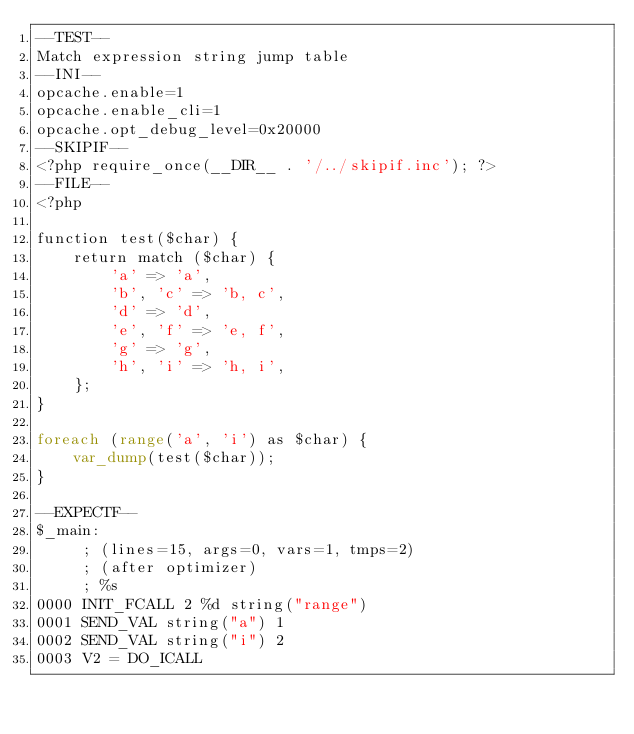<code> <loc_0><loc_0><loc_500><loc_500><_PHP_>--TEST--
Match expression string jump table
--INI--
opcache.enable=1
opcache.enable_cli=1
opcache.opt_debug_level=0x20000
--SKIPIF--
<?php require_once(__DIR__ . '/../skipif.inc'); ?>
--FILE--
<?php

function test($char) {
    return match ($char) {
        'a' => 'a',
        'b', 'c' => 'b, c',
        'd' => 'd',
        'e', 'f' => 'e, f',
        'g' => 'g',
        'h', 'i' => 'h, i',
    };
}

foreach (range('a', 'i') as $char) {
    var_dump(test($char));
}

--EXPECTF--
$_main:
     ; (lines=15, args=0, vars=1, tmps=2)
     ; (after optimizer)
     ; %s
0000 INIT_FCALL 2 %d string("range")
0001 SEND_VAL string("a") 1
0002 SEND_VAL string("i") 2
0003 V2 = DO_ICALL</code> 